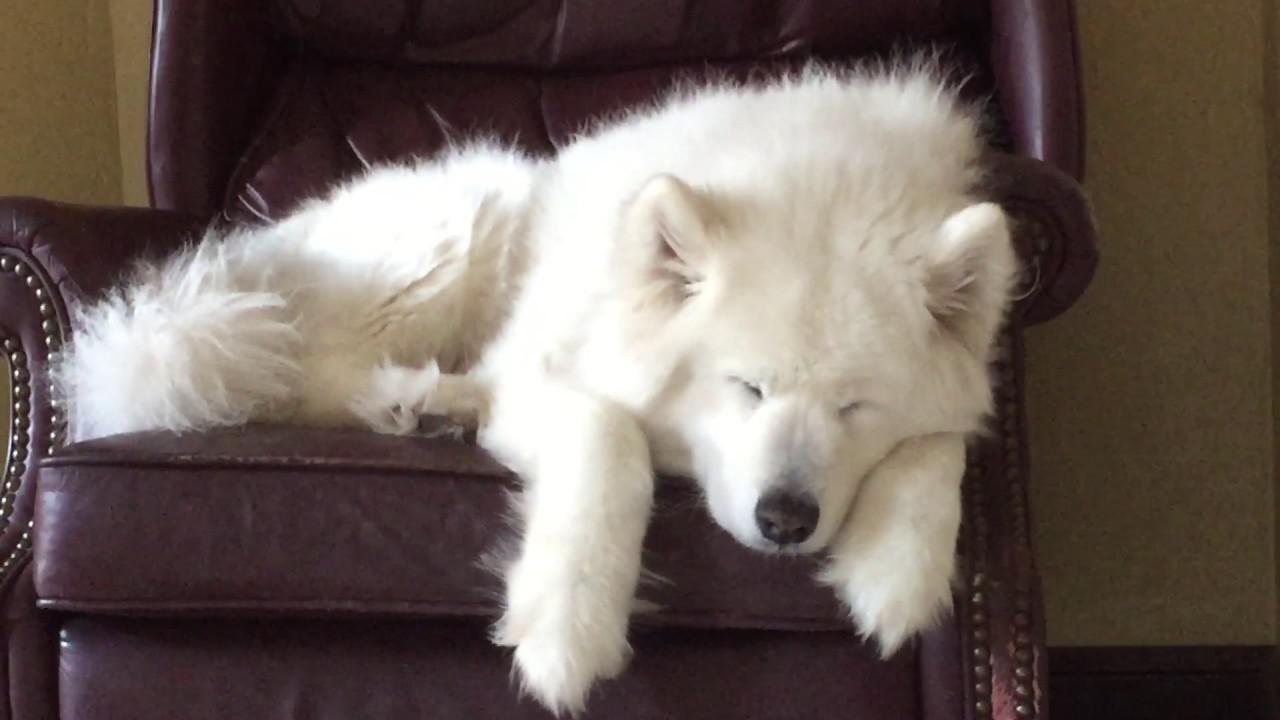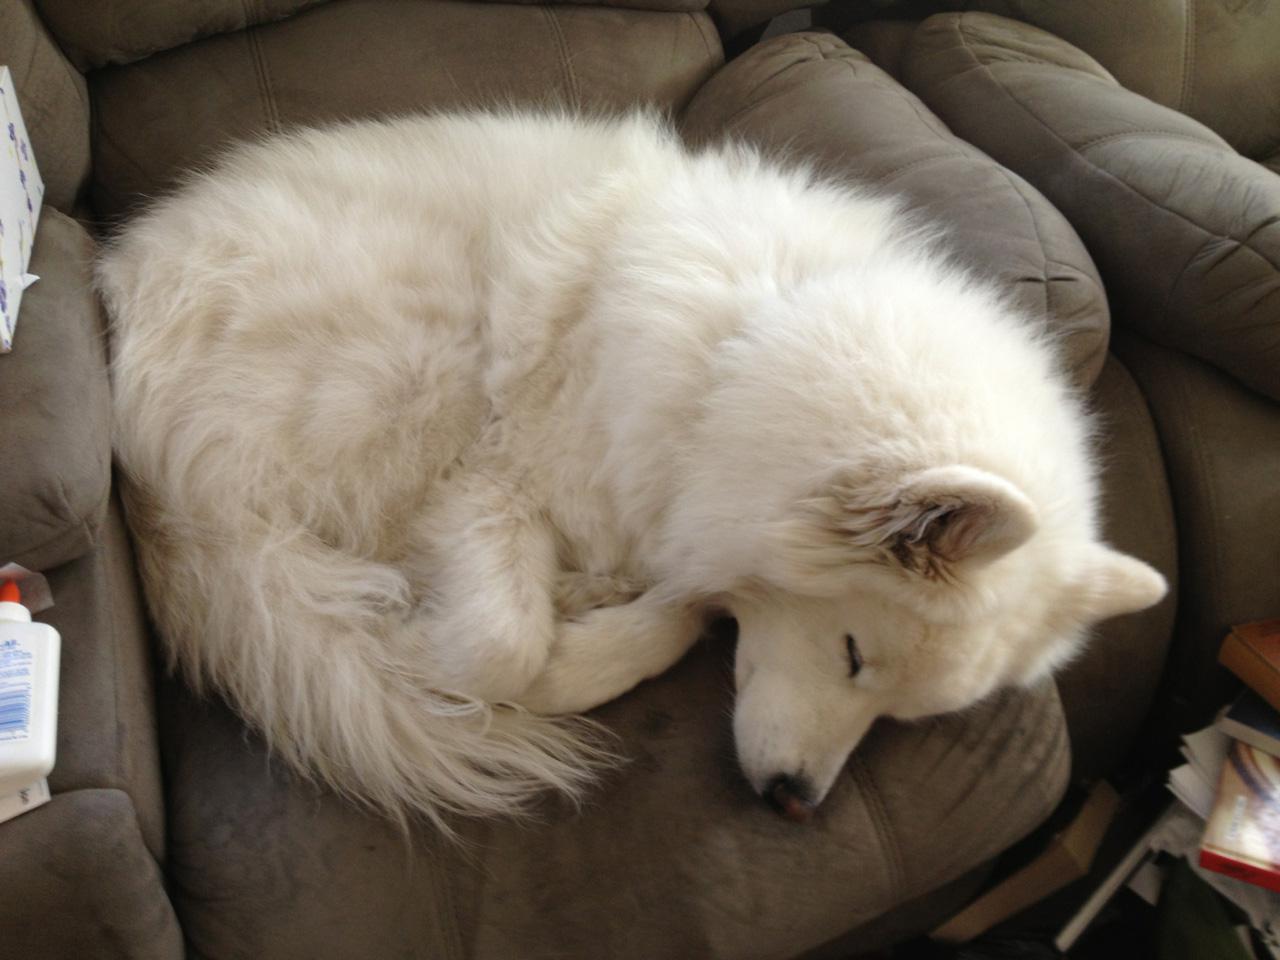The first image is the image on the left, the second image is the image on the right. Considering the images on both sides, is "One image shows a white dog sleeping on a hard tile floor." valid? Answer yes or no. No. The first image is the image on the left, the second image is the image on the right. Analyze the images presented: Is the assertion "The dog in one of the images is sleeping on a wooden surface." valid? Answer yes or no. No. 